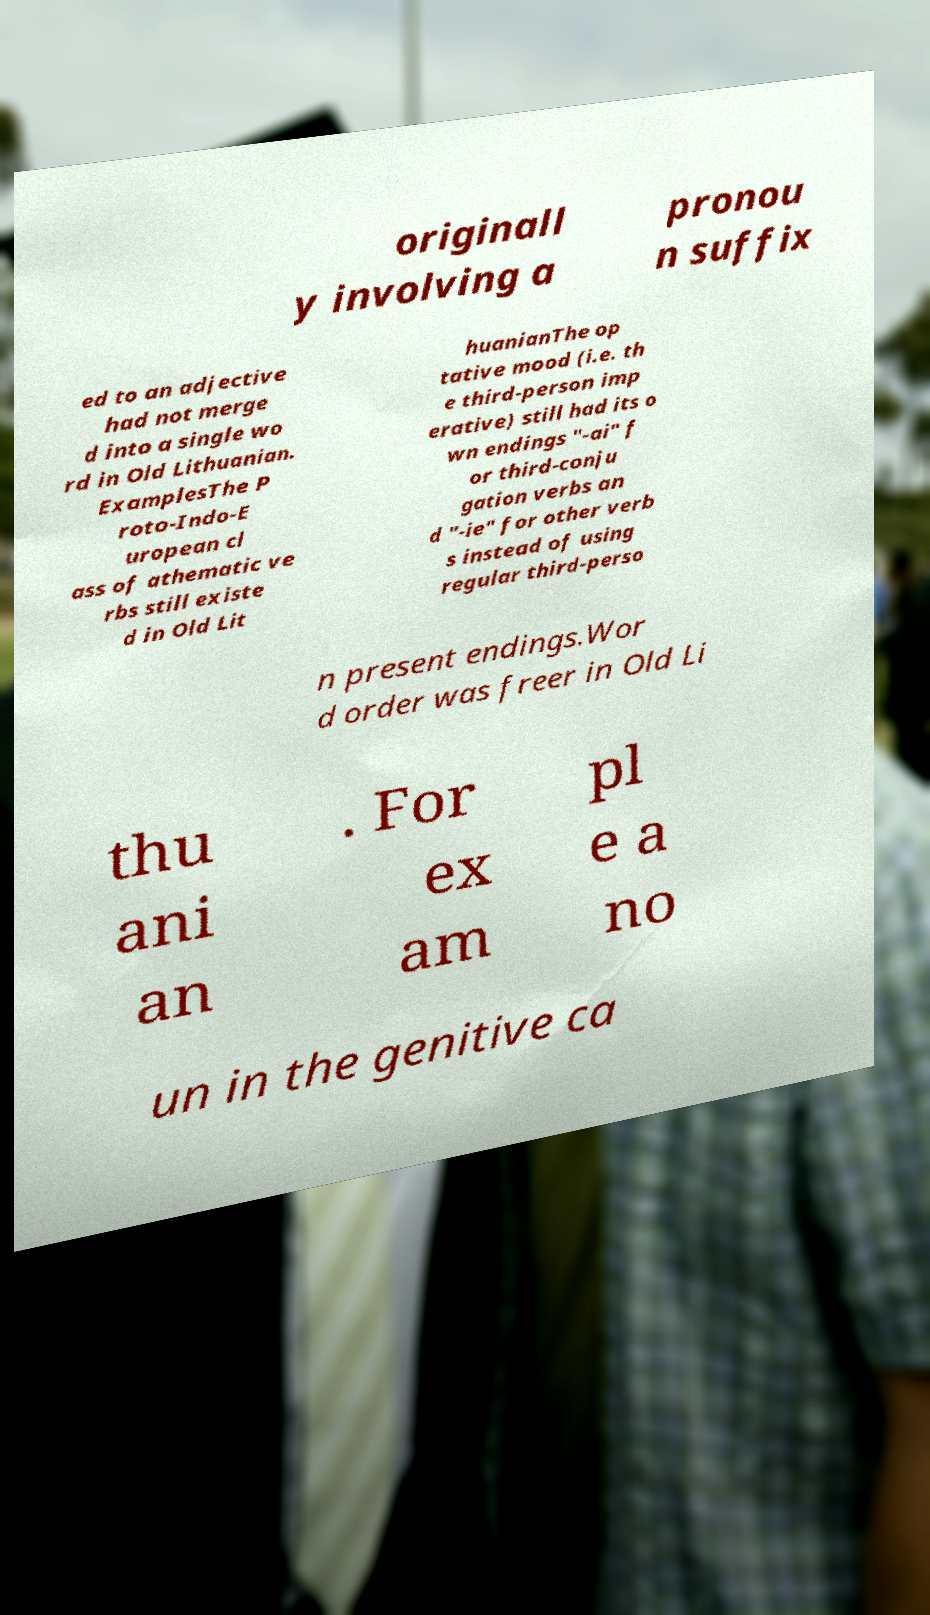Please read and relay the text visible in this image. What does it say? originall y involving a pronou n suffix ed to an adjective had not merge d into a single wo rd in Old Lithuanian. ExamplesThe P roto-Indo-E uropean cl ass of athematic ve rbs still existe d in Old Lit huanianThe op tative mood (i.e. th e third-person imp erative) still had its o wn endings "-ai" f or third-conju gation verbs an d "-ie" for other verb s instead of using regular third-perso n present endings.Wor d order was freer in Old Li thu ani an . For ex am pl e a no un in the genitive ca 